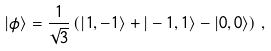<formula> <loc_0><loc_0><loc_500><loc_500>| \phi \rangle = \frac { 1 } { \sqrt { 3 } } \left ( | 1 , - 1 \rangle + | - 1 , 1 \rangle - | 0 , 0 \rangle \right ) \, ,</formula> 